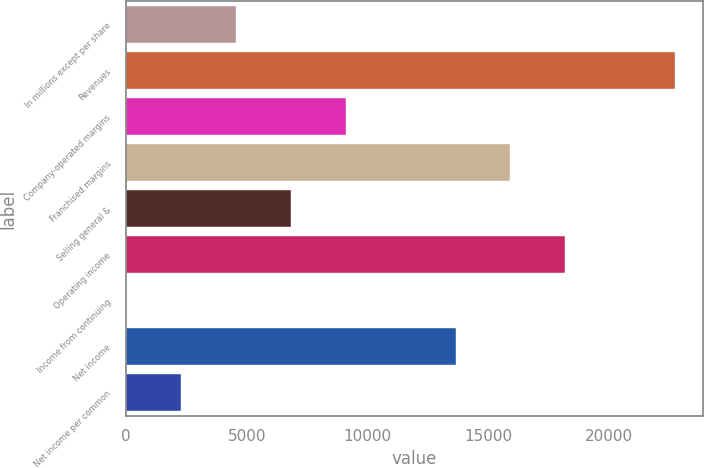Convert chart to OTSL. <chart><loc_0><loc_0><loc_500><loc_500><bar_chart><fcel>In millions except per share<fcel>Revenues<fcel>Company-operated margins<fcel>Franchised margins<fcel>Selling general &<fcel>Operating income<fcel>Income from continuing<fcel>Net income<fcel>Net income per common<nl><fcel>4552.29<fcel>22745<fcel>9100.47<fcel>15922.7<fcel>6826.38<fcel>18196.8<fcel>4.11<fcel>13648.6<fcel>2278.2<nl></chart> 